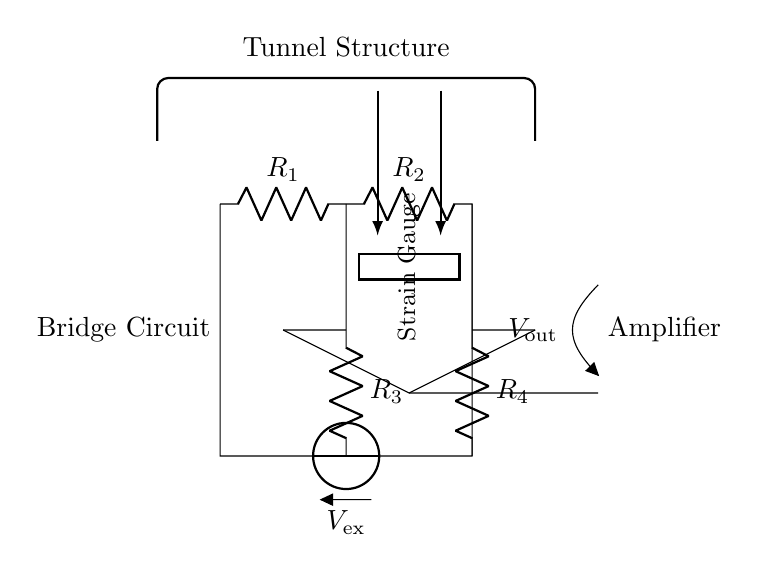What type of circuit is shown? This circuit is a strain gauge bridge circuit. A bridge circuit is characterized by its configuration that includes resistors in a diamond shape, typically used for precise measurement of small changes in resistance. In this case, the strain gauge serves as one of the resistors, allowing for assessment of structural integrity through changes in resistance due to strain.
Answer: strain gauge bridge What is the function of the strain gauge? The strain gauge measures deformation or strain in the tunnel structure. When the structure undergoes stress, the strain gauge changes its resistance in response to this deformation, providing a measurement to assess structural integrity. This change is then translated into electrical signals for monitoring.
Answer: measures strain What is the role of the amplifier in this circuit? The amplifier boosts the signal generated by the strain gauge. Since the changes in resistance from the strain gauge produce very small voltage changes, the amplifier increases this voltage to a level that can be read by measuring instruments, ensuring accurate monitoring of the structural integrity.
Answer: boost signal What is the voltage supply used in the circuit? The voltage supply used in this circuit is denoted as \( V_{\text{ex}} \). This is the excitation voltage applied to the bridge circuit, necessary for the operation of the resistors and the strain gauge. It provides the power needed to generate a measurable output signal.
Answer: \( V_{\text{ex}} \) How do the resistors affect the balance of the bridge? The resistors \( R_1 \), \( R_2 \), \( R_3 \), and \( R_4 \) determine the balance of the bridge. If all resistors are equal, the bridge is balanced, and the output voltage is zero. When the strain gauge changes its resistance, it unbalances the bridge, leading to a measurable output voltage. This principle allows for the detection of strain by observing the output voltage changes.
Answer: resistors balance bridge What is indicated by \( V_{\text{out}} \) in this circuit? \( V_{\text{out}} \) represents the output voltage from the amplifier, which indicates the change in voltage due to the strain measured by the gauge. It is directly related to the changes in resistance caused by strain in the tunnel structure, providing critical data for assessing structural health.
Answer: output voltage 